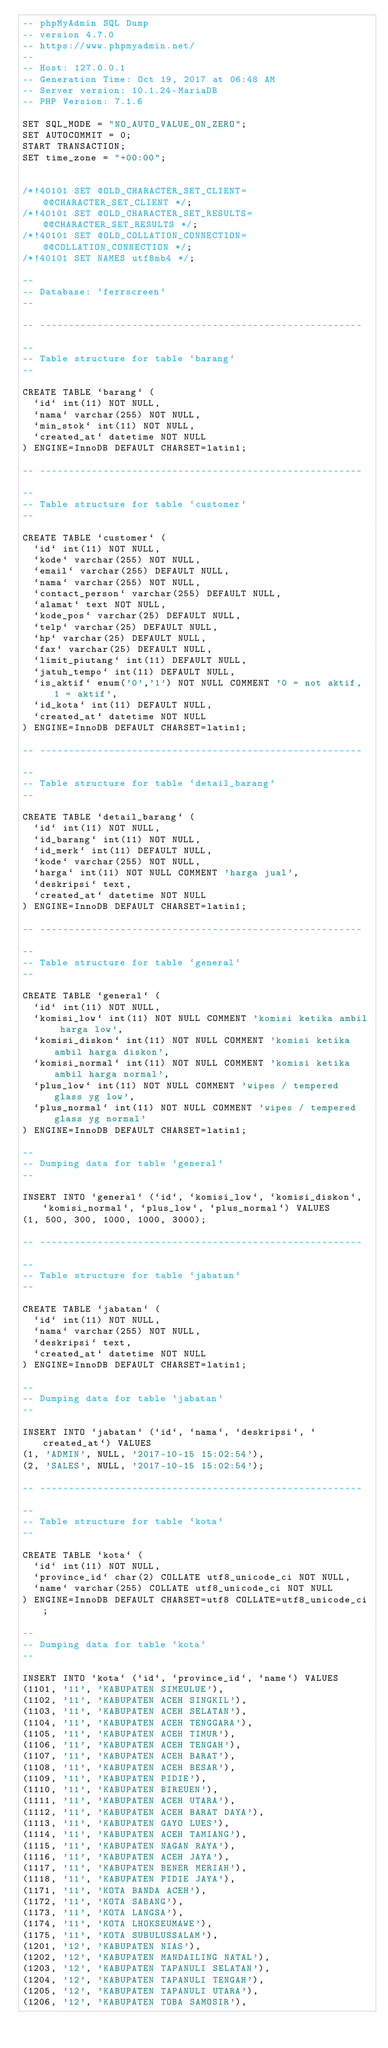Convert code to text. <code><loc_0><loc_0><loc_500><loc_500><_SQL_>-- phpMyAdmin SQL Dump
-- version 4.7.0
-- https://www.phpmyadmin.net/
--
-- Host: 127.0.0.1
-- Generation Time: Oct 19, 2017 at 06:48 AM
-- Server version: 10.1.24-MariaDB
-- PHP Version: 7.1.6

SET SQL_MODE = "NO_AUTO_VALUE_ON_ZERO";
SET AUTOCOMMIT = 0;
START TRANSACTION;
SET time_zone = "+00:00";


/*!40101 SET @OLD_CHARACTER_SET_CLIENT=@@CHARACTER_SET_CLIENT */;
/*!40101 SET @OLD_CHARACTER_SET_RESULTS=@@CHARACTER_SET_RESULTS */;
/*!40101 SET @OLD_COLLATION_CONNECTION=@@COLLATION_CONNECTION */;
/*!40101 SET NAMES utf8mb4 */;

--
-- Database: `ferrscreen`
--

-- --------------------------------------------------------

--
-- Table structure for table `barang`
--

CREATE TABLE `barang` (
  `id` int(11) NOT NULL,
  `nama` varchar(255) NOT NULL,
  `min_stok` int(11) NOT NULL,
  `created_at` datetime NOT NULL
) ENGINE=InnoDB DEFAULT CHARSET=latin1;

-- --------------------------------------------------------

--
-- Table structure for table `customer`
--

CREATE TABLE `customer` (
  `id` int(11) NOT NULL,
  `kode` varchar(255) NOT NULL,
  `email` varchar(255) DEFAULT NULL,
  `nama` varchar(255) NOT NULL,
  `contact_person` varchar(255) DEFAULT NULL,
  `alamat` text NOT NULL,
  `kode_pos` varchar(25) DEFAULT NULL,
  `telp` varchar(25) DEFAULT NULL,
  `hp` varchar(25) DEFAULT NULL,
  `fax` varchar(25) DEFAULT NULL,
  `limit_piutang` int(11) DEFAULT NULL,
  `jatuh_tempo` int(11) DEFAULT NULL,
  `is_aktif` enum('0','1') NOT NULL COMMENT '0 = not aktif, 1 = aktif',
  `id_kota` int(11) DEFAULT NULL,
  `created_at` datetime NOT NULL
) ENGINE=InnoDB DEFAULT CHARSET=latin1;

-- --------------------------------------------------------

--
-- Table structure for table `detail_barang`
--

CREATE TABLE `detail_barang` (
  `id` int(11) NOT NULL,
  `id_barang` int(11) NOT NULL,
  `id_merk` int(11) DEFAULT NULL,
  `kode` varchar(255) NOT NULL,
  `harga` int(11) NOT NULL COMMENT 'harga jual',
  `deskripsi` text,
  `created_at` datetime NOT NULL
) ENGINE=InnoDB DEFAULT CHARSET=latin1;

-- --------------------------------------------------------

--
-- Table structure for table `general`
--

CREATE TABLE `general` (
  `id` int(11) NOT NULL,
  `komisi_low` int(11) NOT NULL COMMENT 'komisi ketika ambil harga low',
  `komisi_diskon` int(11) NOT NULL COMMENT 'komisi ketika ambil harga diskon',
  `komisi_normal` int(11) NOT NULL COMMENT 'komisi ketika ambil harga normal',
  `plus_low` int(11) NOT NULL COMMENT 'wipes / tempered glass yg low',
  `plus_normal` int(11) NOT NULL COMMENT 'wipes / tempered glass yg normal'
) ENGINE=InnoDB DEFAULT CHARSET=latin1;

--
-- Dumping data for table `general`
--

INSERT INTO `general` (`id`, `komisi_low`, `komisi_diskon`, `komisi_normal`, `plus_low`, `plus_normal`) VALUES
(1, 500, 300, 1000, 1000, 3000);

-- --------------------------------------------------------

--
-- Table structure for table `jabatan`
--

CREATE TABLE `jabatan` (
  `id` int(11) NOT NULL,
  `nama` varchar(255) NOT NULL,
  `deskripsi` text,
  `created_at` datetime NOT NULL
) ENGINE=InnoDB DEFAULT CHARSET=latin1;

--
-- Dumping data for table `jabatan`
--

INSERT INTO `jabatan` (`id`, `nama`, `deskripsi`, `created_at`) VALUES
(1, 'ADMIN', NULL, '2017-10-15 15:02:54'),
(2, 'SALES', NULL, '2017-10-15 15:02:54');

-- --------------------------------------------------------

--
-- Table structure for table `kota`
--

CREATE TABLE `kota` (
  `id` int(11) NOT NULL,
  `province_id` char(2) COLLATE utf8_unicode_ci NOT NULL,
  `name` varchar(255) COLLATE utf8_unicode_ci NOT NULL
) ENGINE=InnoDB DEFAULT CHARSET=utf8 COLLATE=utf8_unicode_ci;

--
-- Dumping data for table `kota`
--

INSERT INTO `kota` (`id`, `province_id`, `name`) VALUES
(1101, '11', 'KABUPATEN SIMEULUE'),
(1102, '11', 'KABUPATEN ACEH SINGKIL'),
(1103, '11', 'KABUPATEN ACEH SELATAN'),
(1104, '11', 'KABUPATEN ACEH TENGGARA'),
(1105, '11', 'KABUPATEN ACEH TIMUR'),
(1106, '11', 'KABUPATEN ACEH TENGAH'),
(1107, '11', 'KABUPATEN ACEH BARAT'),
(1108, '11', 'KABUPATEN ACEH BESAR'),
(1109, '11', 'KABUPATEN PIDIE'),
(1110, '11', 'KABUPATEN BIREUEN'),
(1111, '11', 'KABUPATEN ACEH UTARA'),
(1112, '11', 'KABUPATEN ACEH BARAT DAYA'),
(1113, '11', 'KABUPATEN GAYO LUES'),
(1114, '11', 'KABUPATEN ACEH TAMIANG'),
(1115, '11', 'KABUPATEN NAGAN RAYA'),
(1116, '11', 'KABUPATEN ACEH JAYA'),
(1117, '11', 'KABUPATEN BENER MERIAH'),
(1118, '11', 'KABUPATEN PIDIE JAYA'),
(1171, '11', 'KOTA BANDA ACEH'),
(1172, '11', 'KOTA SABANG'),
(1173, '11', 'KOTA LANGSA'),
(1174, '11', 'KOTA LHOKSEUMAWE'),
(1175, '11', 'KOTA SUBULUSSALAM'),
(1201, '12', 'KABUPATEN NIAS'),
(1202, '12', 'KABUPATEN MANDAILING NATAL'),
(1203, '12', 'KABUPATEN TAPANULI SELATAN'),
(1204, '12', 'KABUPATEN TAPANULI TENGAH'),
(1205, '12', 'KABUPATEN TAPANULI UTARA'),
(1206, '12', 'KABUPATEN TOBA SAMOSIR'),</code> 